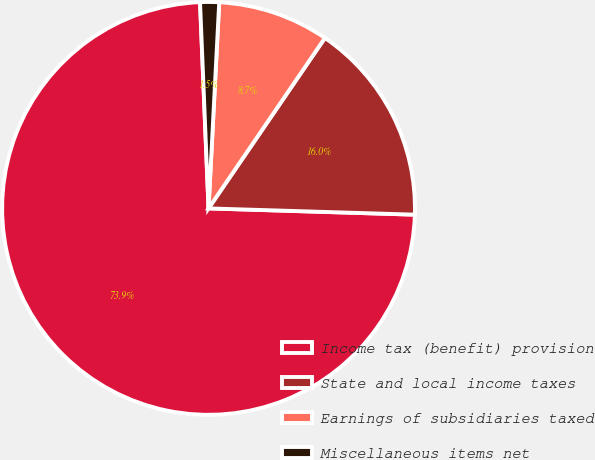<chart> <loc_0><loc_0><loc_500><loc_500><pie_chart><fcel>Income tax (benefit) provision<fcel>State and local income taxes<fcel>Earnings of subsidiaries taxed<fcel>Miscellaneous items net<nl><fcel>73.86%<fcel>15.95%<fcel>8.71%<fcel>1.48%<nl></chart> 